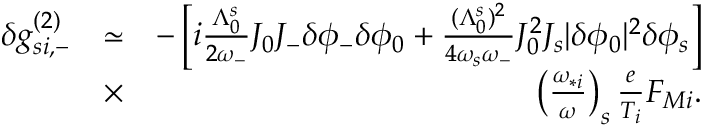<formula> <loc_0><loc_0><loc_500><loc_500>\begin{array} { r l r } { \delta g _ { s i , - } ^ { ( 2 ) } } & { \simeq } & { - \left [ i \frac { \Lambda _ { 0 } ^ { s } } { 2 \omega _ { - } } J _ { 0 } J _ { - } \delta \phi _ { - } \delta \phi _ { 0 } + \frac { ( \Lambda _ { 0 } ^ { s } ) ^ { 2 } } { 4 \omega _ { s } \omega _ { - } } J _ { 0 } ^ { 2 } J _ { s } | \delta \phi _ { 0 } | ^ { 2 } \delta \phi _ { s } \right ] } \\ & { \times } & { \left ( \frac { \omega _ { * i } } { \omega } \right ) _ { s } \frac { e } { T _ { i } } F _ { M i } . } \end{array}</formula> 